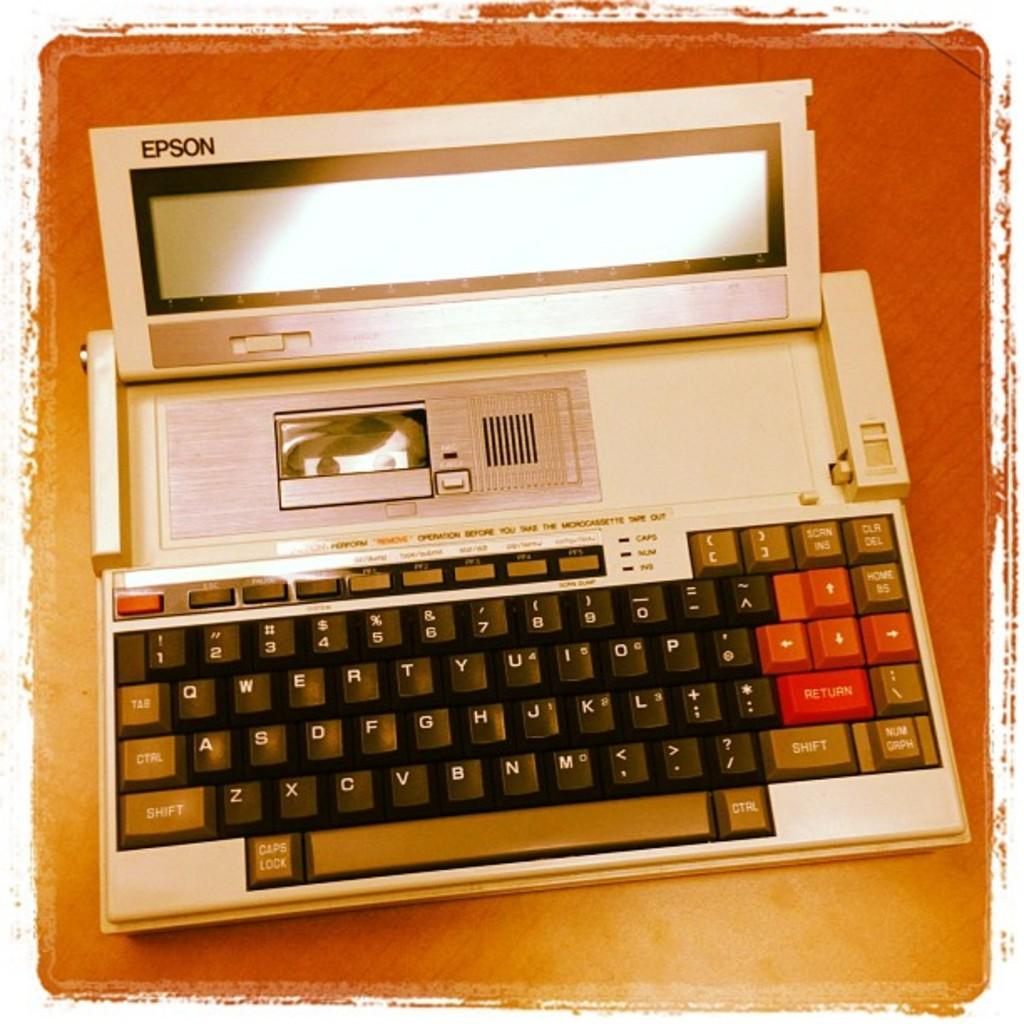<image>
Summarize the visual content of the image. Espon is the name of the first digital type of computer made for personal use. 